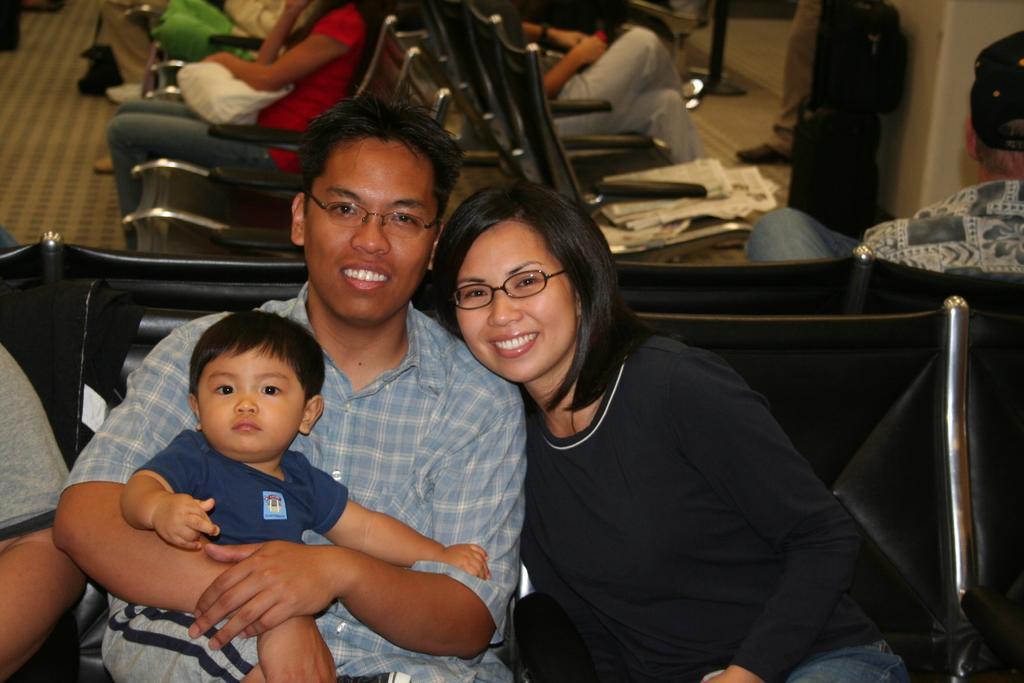In one or two sentences, can you explain what this image depicts? In this image I can see a woman wearing black t shirt, a man wearing blue shirt and a boy wearing blue t shirt and grey short are sitting on the black colored chairs. In the background I can see few chairs, few persons sitting in them, the brown colored floor and few bags. 